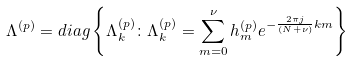<formula> <loc_0><loc_0><loc_500><loc_500>\Lambda ^ { ( p ) } & = d i a g \left \{ \Lambda _ { k } ^ { ( p ) } \colon \Lambda _ { k } ^ { ( p ) } = \sum _ { m = 0 } ^ { \nu } h _ { m } ^ { ( p ) } e ^ { - \frac { 2 \pi j } { ( N + \nu ) } k m } \right \}</formula> 